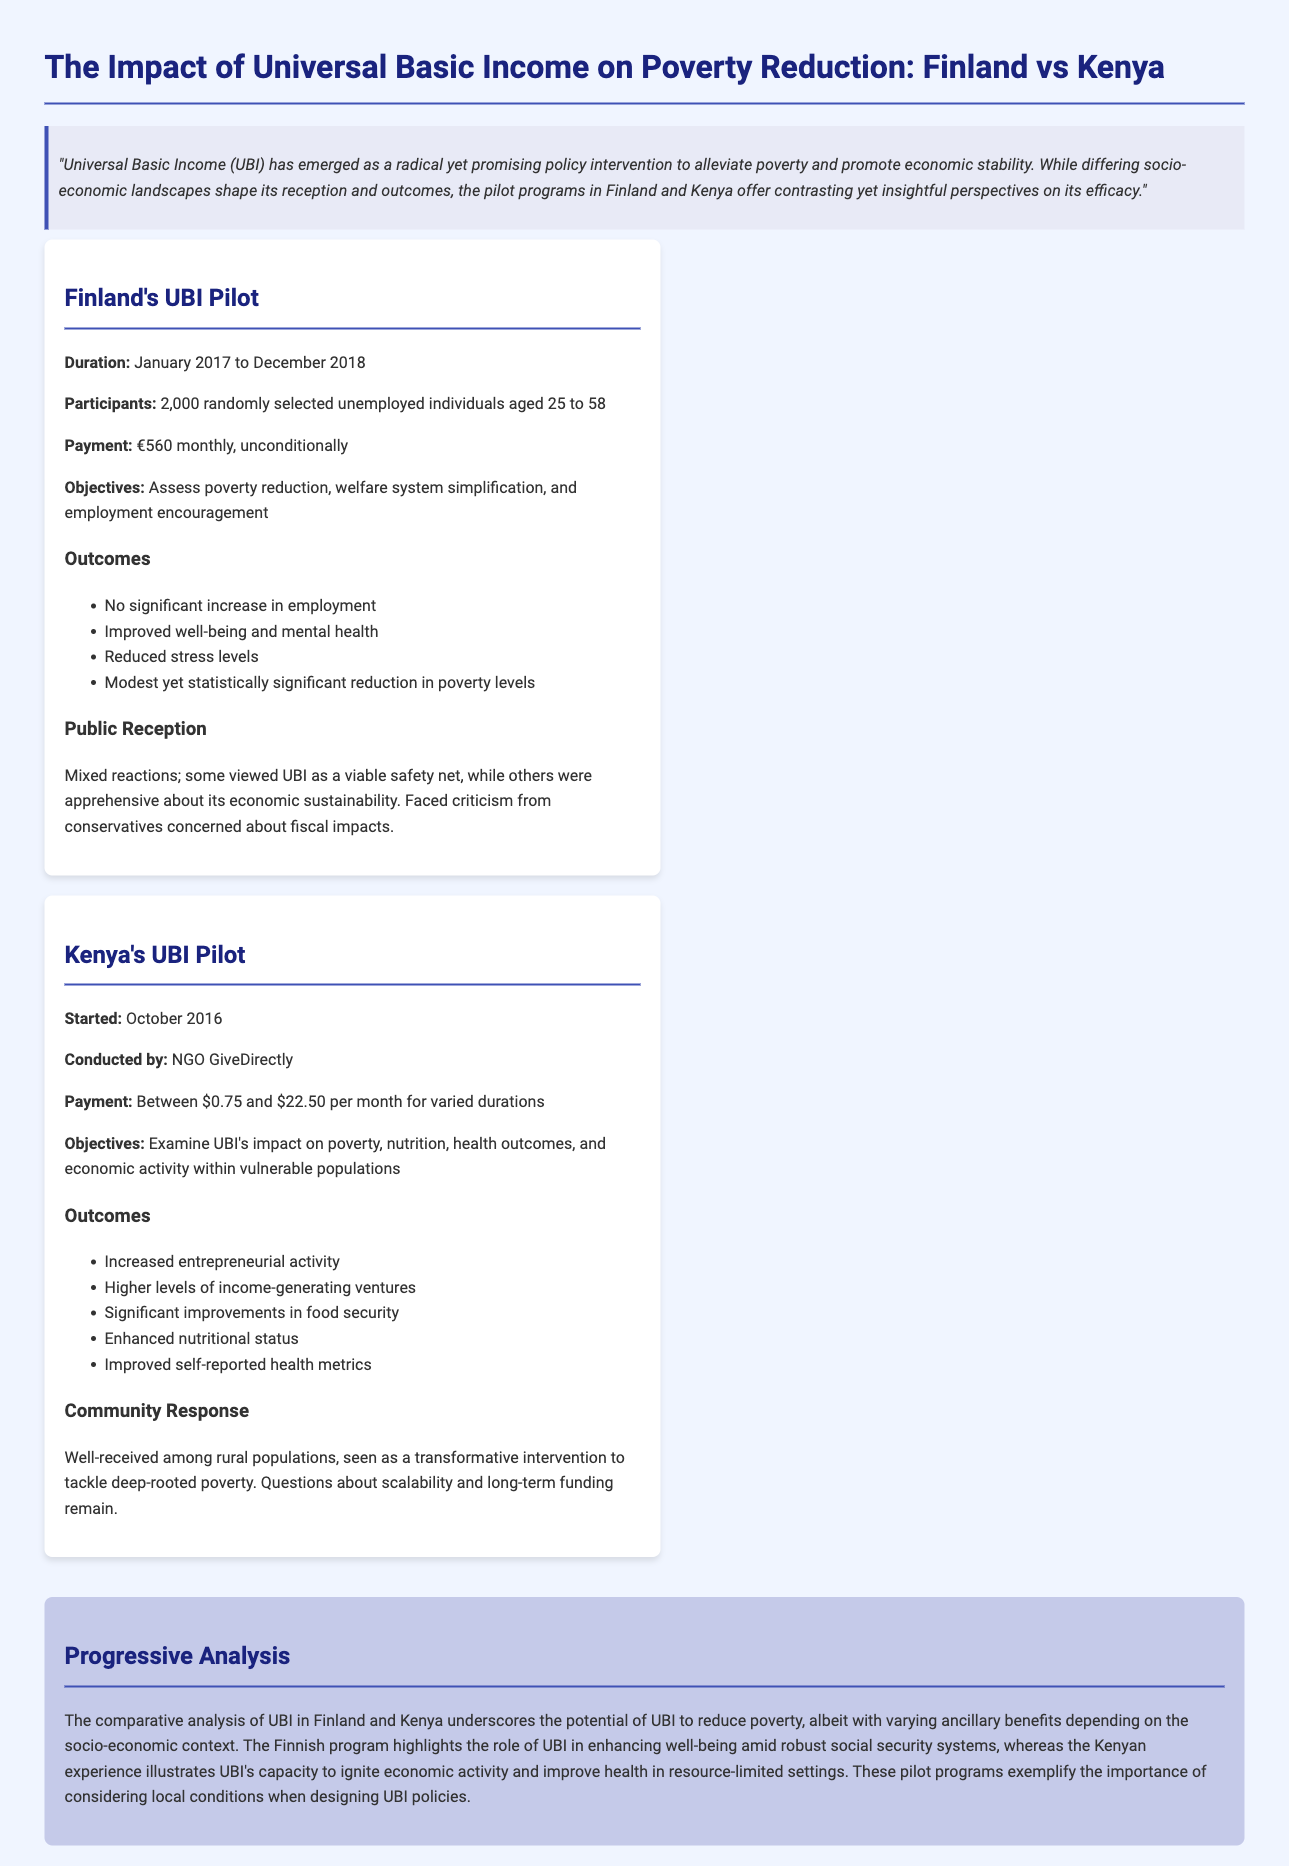What was the duration of Finland's UBI pilot? The duration of Finland's UBI pilot was from January 2017 to December 2018.
Answer: January 2017 to December 2018 How many participants were involved in Finland's UBI pilot? Finland's UBI pilot involved 2,000 randomly selected unemployed individuals aged 25 to 58.
Answer: 2,000 What was the monthly payment amount in Finland's UBI program? The monthly payment amount in Finland's UBI program was €560.
Answer: €560 What notable outcome was observed in Kenya's UBI pilot regarding health? One notable outcome in Kenya's UBI pilot was improved self-reported health metrics.
Answer: Improved self-reported health metrics How was Kenya's UBI pilot received among rural populations? Kenya's UBI pilot was well-received among rural populations and seen as a transformative intervention to tackle deep-rooted poverty.
Answer: Well-received What organization conducted Kenya's UBI pilot? Kenya's UBI pilot was conducted by NGO GiveDirectly.
Answer: NGO GiveDirectly What was a key objective of Finland's UBI pilot? A key objective of Finland's UBI pilot was to assess poverty reduction.
Answer: Assess poverty reduction What does the conclusion highlight about the distinct impacts of UBI? The conclusion highlights the varying ancillary benefits depending on the socio-economic context.
Answer: Varying ancillary benefits depending on the socio-economic context What criticism did Finland's UBI pilot face? Finland's UBI pilot faced criticism from conservatives concerned about fiscal impacts.
Answer: Concerned about fiscal impacts 